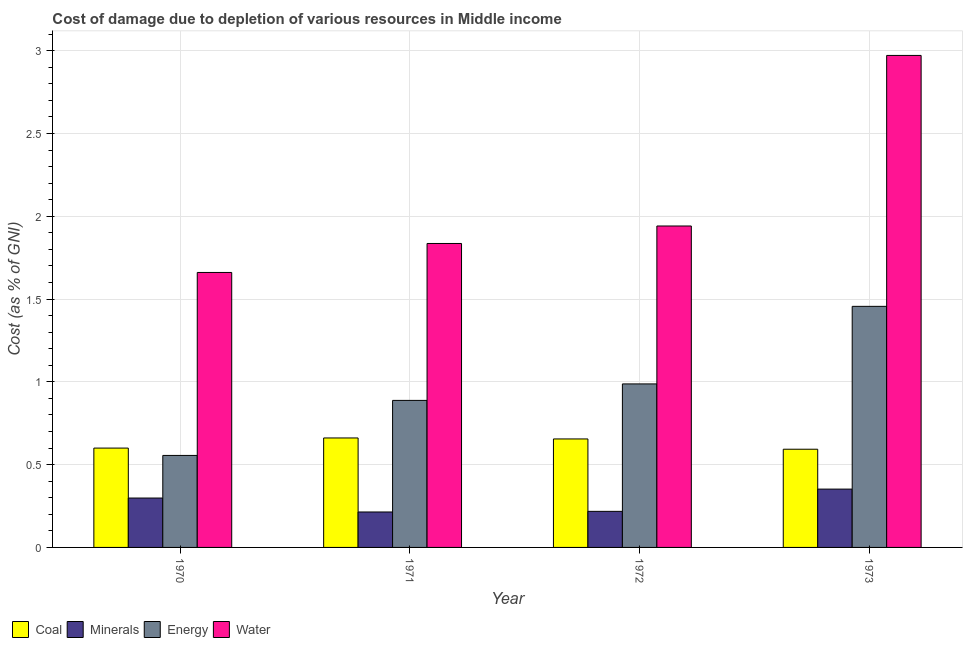How many different coloured bars are there?
Provide a short and direct response. 4. How many groups of bars are there?
Your response must be concise. 4. How many bars are there on the 1st tick from the left?
Provide a short and direct response. 4. What is the cost of damage due to depletion of water in 1970?
Keep it short and to the point. 1.66. Across all years, what is the maximum cost of damage due to depletion of energy?
Your answer should be very brief. 1.46. Across all years, what is the minimum cost of damage due to depletion of energy?
Ensure brevity in your answer.  0.56. In which year was the cost of damage due to depletion of coal minimum?
Give a very brief answer. 1973. What is the total cost of damage due to depletion of coal in the graph?
Your answer should be very brief. 2.51. What is the difference between the cost of damage due to depletion of coal in 1972 and that in 1973?
Make the answer very short. 0.06. What is the difference between the cost of damage due to depletion of energy in 1970 and the cost of damage due to depletion of coal in 1972?
Your answer should be very brief. -0.43. What is the average cost of damage due to depletion of energy per year?
Give a very brief answer. 0.97. In the year 1973, what is the difference between the cost of damage due to depletion of coal and cost of damage due to depletion of water?
Provide a succinct answer. 0. In how many years, is the cost of damage due to depletion of water greater than 0.8 %?
Give a very brief answer. 4. What is the ratio of the cost of damage due to depletion of water in 1970 to that in 1971?
Offer a very short reply. 0.9. Is the cost of damage due to depletion of coal in 1972 less than that in 1973?
Give a very brief answer. No. What is the difference between the highest and the second highest cost of damage due to depletion of minerals?
Offer a terse response. 0.05. What is the difference between the highest and the lowest cost of damage due to depletion of minerals?
Your answer should be very brief. 0.14. Is it the case that in every year, the sum of the cost of damage due to depletion of water and cost of damage due to depletion of minerals is greater than the sum of cost of damage due to depletion of coal and cost of damage due to depletion of energy?
Your answer should be compact. No. What does the 1st bar from the left in 1971 represents?
Give a very brief answer. Coal. What does the 2nd bar from the right in 1972 represents?
Your answer should be very brief. Energy. Is it the case that in every year, the sum of the cost of damage due to depletion of coal and cost of damage due to depletion of minerals is greater than the cost of damage due to depletion of energy?
Your response must be concise. No. Are all the bars in the graph horizontal?
Give a very brief answer. No. What is the difference between two consecutive major ticks on the Y-axis?
Offer a very short reply. 0.5. Are the values on the major ticks of Y-axis written in scientific E-notation?
Your answer should be very brief. No. Does the graph contain any zero values?
Ensure brevity in your answer.  No. Does the graph contain grids?
Provide a short and direct response. Yes. How many legend labels are there?
Provide a succinct answer. 4. What is the title of the graph?
Offer a terse response. Cost of damage due to depletion of various resources in Middle income . Does "CO2 damage" appear as one of the legend labels in the graph?
Your response must be concise. No. What is the label or title of the X-axis?
Provide a succinct answer. Year. What is the label or title of the Y-axis?
Provide a short and direct response. Cost (as % of GNI). What is the Cost (as % of GNI) in Coal in 1970?
Offer a very short reply. 0.6. What is the Cost (as % of GNI) in Minerals in 1970?
Keep it short and to the point. 0.3. What is the Cost (as % of GNI) of Energy in 1970?
Offer a very short reply. 0.56. What is the Cost (as % of GNI) of Water in 1970?
Give a very brief answer. 1.66. What is the Cost (as % of GNI) of Coal in 1971?
Make the answer very short. 0.66. What is the Cost (as % of GNI) in Minerals in 1971?
Offer a terse response. 0.21. What is the Cost (as % of GNI) in Energy in 1971?
Offer a terse response. 0.89. What is the Cost (as % of GNI) in Water in 1971?
Provide a short and direct response. 1.84. What is the Cost (as % of GNI) in Coal in 1972?
Ensure brevity in your answer.  0.66. What is the Cost (as % of GNI) of Minerals in 1972?
Provide a short and direct response. 0.22. What is the Cost (as % of GNI) of Energy in 1972?
Your answer should be very brief. 0.99. What is the Cost (as % of GNI) in Water in 1972?
Your answer should be compact. 1.94. What is the Cost (as % of GNI) of Coal in 1973?
Your response must be concise. 0.59. What is the Cost (as % of GNI) in Minerals in 1973?
Ensure brevity in your answer.  0.35. What is the Cost (as % of GNI) of Energy in 1973?
Keep it short and to the point. 1.46. What is the Cost (as % of GNI) of Water in 1973?
Offer a terse response. 2.97. Across all years, what is the maximum Cost (as % of GNI) in Coal?
Your response must be concise. 0.66. Across all years, what is the maximum Cost (as % of GNI) of Minerals?
Provide a succinct answer. 0.35. Across all years, what is the maximum Cost (as % of GNI) of Energy?
Your answer should be very brief. 1.46. Across all years, what is the maximum Cost (as % of GNI) of Water?
Provide a short and direct response. 2.97. Across all years, what is the minimum Cost (as % of GNI) in Coal?
Your answer should be very brief. 0.59. Across all years, what is the minimum Cost (as % of GNI) of Minerals?
Your answer should be very brief. 0.21. Across all years, what is the minimum Cost (as % of GNI) in Energy?
Ensure brevity in your answer.  0.56. Across all years, what is the minimum Cost (as % of GNI) in Water?
Offer a very short reply. 1.66. What is the total Cost (as % of GNI) of Coal in the graph?
Offer a terse response. 2.51. What is the total Cost (as % of GNI) in Minerals in the graph?
Make the answer very short. 1.08. What is the total Cost (as % of GNI) of Energy in the graph?
Make the answer very short. 3.89. What is the total Cost (as % of GNI) in Water in the graph?
Your response must be concise. 8.41. What is the difference between the Cost (as % of GNI) of Coal in 1970 and that in 1971?
Offer a very short reply. -0.06. What is the difference between the Cost (as % of GNI) in Minerals in 1970 and that in 1971?
Ensure brevity in your answer.  0.08. What is the difference between the Cost (as % of GNI) of Energy in 1970 and that in 1971?
Keep it short and to the point. -0.33. What is the difference between the Cost (as % of GNI) of Water in 1970 and that in 1971?
Offer a very short reply. -0.17. What is the difference between the Cost (as % of GNI) in Coal in 1970 and that in 1972?
Ensure brevity in your answer.  -0.06. What is the difference between the Cost (as % of GNI) in Minerals in 1970 and that in 1972?
Provide a short and direct response. 0.08. What is the difference between the Cost (as % of GNI) of Energy in 1970 and that in 1972?
Your answer should be compact. -0.43. What is the difference between the Cost (as % of GNI) of Water in 1970 and that in 1972?
Your answer should be compact. -0.28. What is the difference between the Cost (as % of GNI) in Coal in 1970 and that in 1973?
Make the answer very short. 0.01. What is the difference between the Cost (as % of GNI) in Minerals in 1970 and that in 1973?
Provide a short and direct response. -0.05. What is the difference between the Cost (as % of GNI) of Energy in 1970 and that in 1973?
Provide a short and direct response. -0.9. What is the difference between the Cost (as % of GNI) of Water in 1970 and that in 1973?
Make the answer very short. -1.31. What is the difference between the Cost (as % of GNI) in Coal in 1971 and that in 1972?
Give a very brief answer. 0.01. What is the difference between the Cost (as % of GNI) in Minerals in 1971 and that in 1972?
Your answer should be compact. -0. What is the difference between the Cost (as % of GNI) in Energy in 1971 and that in 1972?
Your response must be concise. -0.1. What is the difference between the Cost (as % of GNI) in Water in 1971 and that in 1972?
Offer a terse response. -0.11. What is the difference between the Cost (as % of GNI) in Coal in 1971 and that in 1973?
Your response must be concise. 0.07. What is the difference between the Cost (as % of GNI) of Minerals in 1971 and that in 1973?
Keep it short and to the point. -0.14. What is the difference between the Cost (as % of GNI) in Energy in 1971 and that in 1973?
Your response must be concise. -0.57. What is the difference between the Cost (as % of GNI) in Water in 1971 and that in 1973?
Provide a short and direct response. -1.14. What is the difference between the Cost (as % of GNI) in Coal in 1972 and that in 1973?
Ensure brevity in your answer.  0.06. What is the difference between the Cost (as % of GNI) in Minerals in 1972 and that in 1973?
Your response must be concise. -0.13. What is the difference between the Cost (as % of GNI) of Energy in 1972 and that in 1973?
Keep it short and to the point. -0.47. What is the difference between the Cost (as % of GNI) of Water in 1972 and that in 1973?
Your response must be concise. -1.03. What is the difference between the Cost (as % of GNI) in Coal in 1970 and the Cost (as % of GNI) in Minerals in 1971?
Offer a terse response. 0.39. What is the difference between the Cost (as % of GNI) of Coal in 1970 and the Cost (as % of GNI) of Energy in 1971?
Offer a very short reply. -0.29. What is the difference between the Cost (as % of GNI) of Coal in 1970 and the Cost (as % of GNI) of Water in 1971?
Offer a very short reply. -1.24. What is the difference between the Cost (as % of GNI) in Minerals in 1970 and the Cost (as % of GNI) in Energy in 1971?
Provide a short and direct response. -0.59. What is the difference between the Cost (as % of GNI) in Minerals in 1970 and the Cost (as % of GNI) in Water in 1971?
Your answer should be very brief. -1.54. What is the difference between the Cost (as % of GNI) of Energy in 1970 and the Cost (as % of GNI) of Water in 1971?
Make the answer very short. -1.28. What is the difference between the Cost (as % of GNI) of Coal in 1970 and the Cost (as % of GNI) of Minerals in 1972?
Provide a short and direct response. 0.38. What is the difference between the Cost (as % of GNI) of Coal in 1970 and the Cost (as % of GNI) of Energy in 1972?
Your response must be concise. -0.39. What is the difference between the Cost (as % of GNI) in Coal in 1970 and the Cost (as % of GNI) in Water in 1972?
Keep it short and to the point. -1.34. What is the difference between the Cost (as % of GNI) in Minerals in 1970 and the Cost (as % of GNI) in Energy in 1972?
Keep it short and to the point. -0.69. What is the difference between the Cost (as % of GNI) in Minerals in 1970 and the Cost (as % of GNI) in Water in 1972?
Your answer should be very brief. -1.64. What is the difference between the Cost (as % of GNI) in Energy in 1970 and the Cost (as % of GNI) in Water in 1972?
Your answer should be very brief. -1.39. What is the difference between the Cost (as % of GNI) in Coal in 1970 and the Cost (as % of GNI) in Minerals in 1973?
Your answer should be compact. 0.25. What is the difference between the Cost (as % of GNI) in Coal in 1970 and the Cost (as % of GNI) in Energy in 1973?
Your response must be concise. -0.86. What is the difference between the Cost (as % of GNI) of Coal in 1970 and the Cost (as % of GNI) of Water in 1973?
Ensure brevity in your answer.  -2.37. What is the difference between the Cost (as % of GNI) in Minerals in 1970 and the Cost (as % of GNI) in Energy in 1973?
Offer a very short reply. -1.16. What is the difference between the Cost (as % of GNI) in Minerals in 1970 and the Cost (as % of GNI) in Water in 1973?
Offer a very short reply. -2.67. What is the difference between the Cost (as % of GNI) of Energy in 1970 and the Cost (as % of GNI) of Water in 1973?
Give a very brief answer. -2.42. What is the difference between the Cost (as % of GNI) in Coal in 1971 and the Cost (as % of GNI) in Minerals in 1972?
Keep it short and to the point. 0.44. What is the difference between the Cost (as % of GNI) of Coal in 1971 and the Cost (as % of GNI) of Energy in 1972?
Your answer should be compact. -0.33. What is the difference between the Cost (as % of GNI) in Coal in 1971 and the Cost (as % of GNI) in Water in 1972?
Provide a short and direct response. -1.28. What is the difference between the Cost (as % of GNI) of Minerals in 1971 and the Cost (as % of GNI) of Energy in 1972?
Provide a short and direct response. -0.77. What is the difference between the Cost (as % of GNI) in Minerals in 1971 and the Cost (as % of GNI) in Water in 1972?
Provide a short and direct response. -1.73. What is the difference between the Cost (as % of GNI) in Energy in 1971 and the Cost (as % of GNI) in Water in 1972?
Offer a terse response. -1.05. What is the difference between the Cost (as % of GNI) in Coal in 1971 and the Cost (as % of GNI) in Minerals in 1973?
Make the answer very short. 0.31. What is the difference between the Cost (as % of GNI) of Coal in 1971 and the Cost (as % of GNI) of Energy in 1973?
Provide a short and direct response. -0.79. What is the difference between the Cost (as % of GNI) in Coal in 1971 and the Cost (as % of GNI) in Water in 1973?
Keep it short and to the point. -2.31. What is the difference between the Cost (as % of GNI) in Minerals in 1971 and the Cost (as % of GNI) in Energy in 1973?
Ensure brevity in your answer.  -1.24. What is the difference between the Cost (as % of GNI) in Minerals in 1971 and the Cost (as % of GNI) in Water in 1973?
Ensure brevity in your answer.  -2.76. What is the difference between the Cost (as % of GNI) of Energy in 1971 and the Cost (as % of GNI) of Water in 1973?
Your answer should be very brief. -2.08. What is the difference between the Cost (as % of GNI) of Coal in 1972 and the Cost (as % of GNI) of Minerals in 1973?
Offer a very short reply. 0.3. What is the difference between the Cost (as % of GNI) in Coal in 1972 and the Cost (as % of GNI) in Energy in 1973?
Ensure brevity in your answer.  -0.8. What is the difference between the Cost (as % of GNI) in Coal in 1972 and the Cost (as % of GNI) in Water in 1973?
Provide a short and direct response. -2.32. What is the difference between the Cost (as % of GNI) of Minerals in 1972 and the Cost (as % of GNI) of Energy in 1973?
Your answer should be very brief. -1.24. What is the difference between the Cost (as % of GNI) of Minerals in 1972 and the Cost (as % of GNI) of Water in 1973?
Provide a succinct answer. -2.75. What is the difference between the Cost (as % of GNI) of Energy in 1972 and the Cost (as % of GNI) of Water in 1973?
Your answer should be compact. -1.98. What is the average Cost (as % of GNI) of Coal per year?
Offer a very short reply. 0.63. What is the average Cost (as % of GNI) of Minerals per year?
Offer a terse response. 0.27. What is the average Cost (as % of GNI) in Energy per year?
Offer a very short reply. 0.97. What is the average Cost (as % of GNI) of Water per year?
Offer a very short reply. 2.1. In the year 1970, what is the difference between the Cost (as % of GNI) of Coal and Cost (as % of GNI) of Minerals?
Keep it short and to the point. 0.3. In the year 1970, what is the difference between the Cost (as % of GNI) in Coal and Cost (as % of GNI) in Energy?
Your answer should be very brief. 0.04. In the year 1970, what is the difference between the Cost (as % of GNI) of Coal and Cost (as % of GNI) of Water?
Make the answer very short. -1.06. In the year 1970, what is the difference between the Cost (as % of GNI) of Minerals and Cost (as % of GNI) of Energy?
Make the answer very short. -0.26. In the year 1970, what is the difference between the Cost (as % of GNI) of Minerals and Cost (as % of GNI) of Water?
Make the answer very short. -1.36. In the year 1970, what is the difference between the Cost (as % of GNI) of Energy and Cost (as % of GNI) of Water?
Make the answer very short. -1.11. In the year 1971, what is the difference between the Cost (as % of GNI) in Coal and Cost (as % of GNI) in Minerals?
Your answer should be very brief. 0.45. In the year 1971, what is the difference between the Cost (as % of GNI) in Coal and Cost (as % of GNI) in Energy?
Your answer should be very brief. -0.23. In the year 1971, what is the difference between the Cost (as % of GNI) of Coal and Cost (as % of GNI) of Water?
Your answer should be very brief. -1.17. In the year 1971, what is the difference between the Cost (as % of GNI) of Minerals and Cost (as % of GNI) of Energy?
Offer a very short reply. -0.67. In the year 1971, what is the difference between the Cost (as % of GNI) in Minerals and Cost (as % of GNI) in Water?
Make the answer very short. -1.62. In the year 1971, what is the difference between the Cost (as % of GNI) of Energy and Cost (as % of GNI) of Water?
Make the answer very short. -0.95. In the year 1972, what is the difference between the Cost (as % of GNI) in Coal and Cost (as % of GNI) in Minerals?
Your answer should be compact. 0.44. In the year 1972, what is the difference between the Cost (as % of GNI) of Coal and Cost (as % of GNI) of Energy?
Offer a very short reply. -0.33. In the year 1972, what is the difference between the Cost (as % of GNI) in Coal and Cost (as % of GNI) in Water?
Offer a terse response. -1.29. In the year 1972, what is the difference between the Cost (as % of GNI) of Minerals and Cost (as % of GNI) of Energy?
Your response must be concise. -0.77. In the year 1972, what is the difference between the Cost (as % of GNI) in Minerals and Cost (as % of GNI) in Water?
Offer a terse response. -1.72. In the year 1972, what is the difference between the Cost (as % of GNI) of Energy and Cost (as % of GNI) of Water?
Provide a short and direct response. -0.95. In the year 1973, what is the difference between the Cost (as % of GNI) in Coal and Cost (as % of GNI) in Minerals?
Your answer should be very brief. 0.24. In the year 1973, what is the difference between the Cost (as % of GNI) of Coal and Cost (as % of GNI) of Energy?
Provide a short and direct response. -0.86. In the year 1973, what is the difference between the Cost (as % of GNI) in Coal and Cost (as % of GNI) in Water?
Your answer should be very brief. -2.38. In the year 1973, what is the difference between the Cost (as % of GNI) of Minerals and Cost (as % of GNI) of Energy?
Give a very brief answer. -1.1. In the year 1973, what is the difference between the Cost (as % of GNI) of Minerals and Cost (as % of GNI) of Water?
Provide a succinct answer. -2.62. In the year 1973, what is the difference between the Cost (as % of GNI) of Energy and Cost (as % of GNI) of Water?
Your response must be concise. -1.52. What is the ratio of the Cost (as % of GNI) in Coal in 1970 to that in 1971?
Provide a succinct answer. 0.91. What is the ratio of the Cost (as % of GNI) of Minerals in 1970 to that in 1971?
Provide a short and direct response. 1.39. What is the ratio of the Cost (as % of GNI) of Energy in 1970 to that in 1971?
Keep it short and to the point. 0.63. What is the ratio of the Cost (as % of GNI) of Water in 1970 to that in 1971?
Offer a terse response. 0.9. What is the ratio of the Cost (as % of GNI) in Coal in 1970 to that in 1972?
Provide a succinct answer. 0.92. What is the ratio of the Cost (as % of GNI) of Minerals in 1970 to that in 1972?
Ensure brevity in your answer.  1.37. What is the ratio of the Cost (as % of GNI) of Energy in 1970 to that in 1972?
Your answer should be very brief. 0.56. What is the ratio of the Cost (as % of GNI) in Water in 1970 to that in 1972?
Make the answer very short. 0.86. What is the ratio of the Cost (as % of GNI) of Coal in 1970 to that in 1973?
Make the answer very short. 1.01. What is the ratio of the Cost (as % of GNI) in Minerals in 1970 to that in 1973?
Keep it short and to the point. 0.85. What is the ratio of the Cost (as % of GNI) of Energy in 1970 to that in 1973?
Offer a terse response. 0.38. What is the ratio of the Cost (as % of GNI) of Water in 1970 to that in 1973?
Ensure brevity in your answer.  0.56. What is the ratio of the Cost (as % of GNI) of Coal in 1971 to that in 1972?
Your answer should be very brief. 1.01. What is the ratio of the Cost (as % of GNI) in Minerals in 1971 to that in 1972?
Provide a succinct answer. 0.98. What is the ratio of the Cost (as % of GNI) in Energy in 1971 to that in 1972?
Make the answer very short. 0.9. What is the ratio of the Cost (as % of GNI) in Water in 1971 to that in 1972?
Make the answer very short. 0.95. What is the ratio of the Cost (as % of GNI) in Coal in 1971 to that in 1973?
Offer a very short reply. 1.11. What is the ratio of the Cost (as % of GNI) in Minerals in 1971 to that in 1973?
Your answer should be very brief. 0.61. What is the ratio of the Cost (as % of GNI) of Energy in 1971 to that in 1973?
Offer a very short reply. 0.61. What is the ratio of the Cost (as % of GNI) of Water in 1971 to that in 1973?
Give a very brief answer. 0.62. What is the ratio of the Cost (as % of GNI) of Coal in 1972 to that in 1973?
Ensure brevity in your answer.  1.1. What is the ratio of the Cost (as % of GNI) of Minerals in 1972 to that in 1973?
Provide a short and direct response. 0.62. What is the ratio of the Cost (as % of GNI) in Energy in 1972 to that in 1973?
Ensure brevity in your answer.  0.68. What is the ratio of the Cost (as % of GNI) of Water in 1972 to that in 1973?
Provide a short and direct response. 0.65. What is the difference between the highest and the second highest Cost (as % of GNI) in Coal?
Ensure brevity in your answer.  0.01. What is the difference between the highest and the second highest Cost (as % of GNI) of Minerals?
Keep it short and to the point. 0.05. What is the difference between the highest and the second highest Cost (as % of GNI) in Energy?
Your answer should be very brief. 0.47. What is the difference between the highest and the second highest Cost (as % of GNI) in Water?
Your answer should be very brief. 1.03. What is the difference between the highest and the lowest Cost (as % of GNI) in Coal?
Offer a very short reply. 0.07. What is the difference between the highest and the lowest Cost (as % of GNI) in Minerals?
Make the answer very short. 0.14. What is the difference between the highest and the lowest Cost (as % of GNI) in Energy?
Offer a terse response. 0.9. What is the difference between the highest and the lowest Cost (as % of GNI) in Water?
Ensure brevity in your answer.  1.31. 